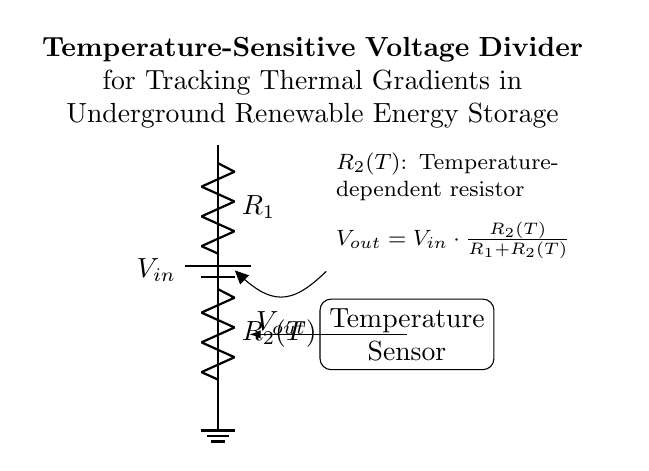What is the function of R2 in this circuit? R2 is a temperature-dependent resistor that varies its resistance based on the temperature influences, thus altering the output voltage.
Answer: Temperature-dependent resistor What is the output voltage formula? The output voltage is given by the equation Vout equals Vin multiplied by the resistance of R2 divided by the sum of R1 and R2. It shows how output relates to input based on the resistances.
Answer: Vout equals Vin times R2 divided by R1 plus R2 What is the total resistance when R1 is 10 ohms and R2 is 20 ohms? The total resistance is the sum of R1 and R2, which is 10 plus 20 equaling 30.
Answer: 30 ohms How does temperature affect Vout? As temperature rises, the resistance of R2 changes, influencing the output voltage according to the voltage divider formula; higher R2 increases Vout, while lower R2 decreases it.
Answer: R2 influences Vout What component is used to measure temperature in the circuit? A temperature sensor measures the temperature by interacting with R2, which adjusts its resistance accordingly.
Answer: Temperature sensor What type of circuit is this? This is a voltage divider circuit designed to provide an output voltage based on the ratio of resistances, specifically influenced by temperature in this case.
Answer: Voltage divider 